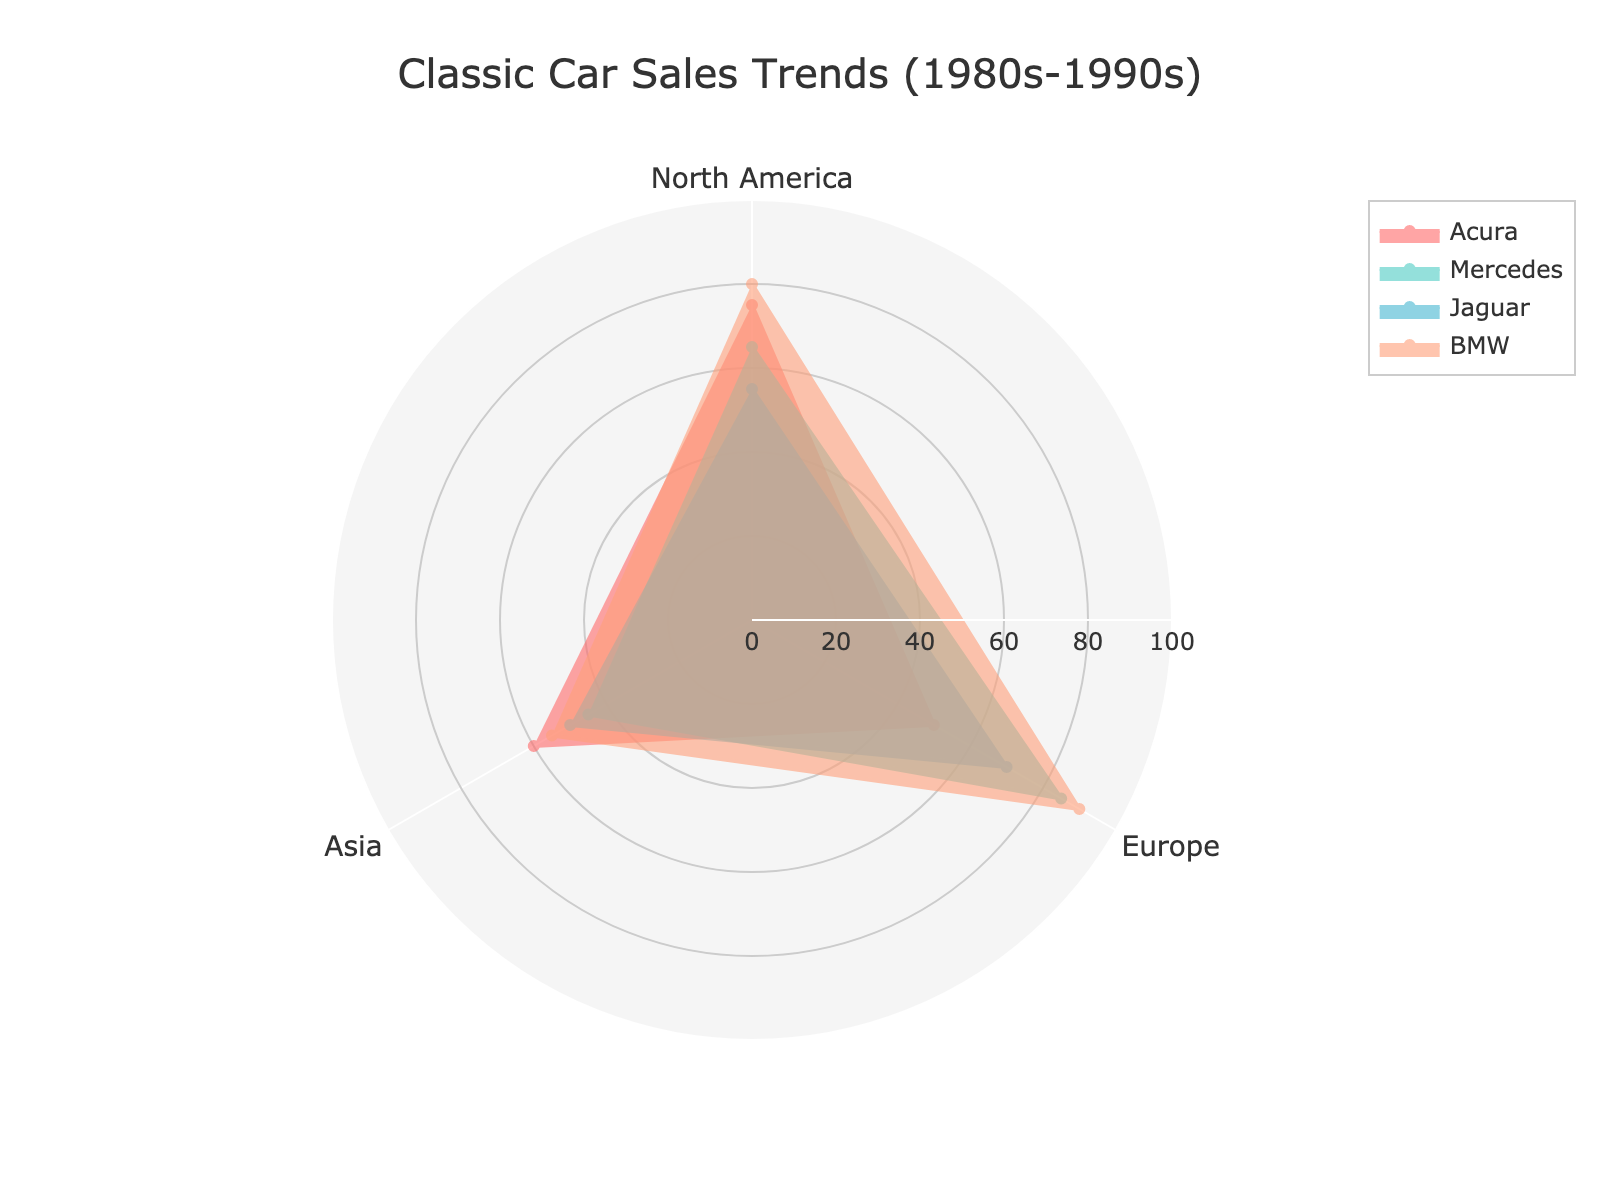How many regions are displayed in the radar chart? The radar chart shows three distinct regions: North America, Europe, and Asia.
Answer: 3 Which car brand has the highest sales in Europe? By looking at the radar chart, the BMW trace reaches the furthest along the European axis, indicating the highest sales.
Answer: BMW What is the average sales value for Acura across all regions? The sales values for Acura in each region are 75 (North America), 50 (Europe), and 60 (Asia). Adding these values and dividing them by 3 gives the average: (75 + 50 + 60) / 3 = 61.7.
Answer: 61.7 Which region shows the lowest sales for Jaguar? The shortest trace for Jaguar can be seen on the Asia axis, indicating the lowest sales.
Answer: Asia How do sales of Mercedes in North America compare to BMW in Asia? The radar chart shows the sales for Mercedes in North America (65) and BMW in Asia (55). Comparing these, Mercedes has higher sales in North America than BMW in Asia.
Answer: Mercedes has higher sales Which brand shows the most consistent sales across all regions? Consistency can be gauged by how similar the values are across the different regions. BMW shows fairly high sales across all regions (80, 90, 55), whereas other brands show more variability.
Answer: BMW If we sum the sales of Mercedes in Europe and Acura in Asia, what is the result? Mercedes in Europe has sales of 85 and Acura in Asia has sales of 60. Summing these values: 85 + 60 = 145.
Answer: 145 Which car brand has the lowest individual sales value, and in which region is it? The lowest individual sales value across all brands is for Jaguar in Asia, with a sales value of 50.
Answer: Jaguar in Asia Compare the sales trend of Acura in North America with the overall trend of Mercedes in Europe and Asia. The sales of Acura in North America (75) are higher than those of Mercedes in both Europe (85) and Asia (45) combined, indicating Acura's higher popularity in North America compared to Mercedes in those two regions.
Answer: Acura higher in North America Which region shows the most significant difference between the highest and lowest sales values among all brands? What is the difference? Europe has the highest sales value for BMW (90) and the lowest for Acura (50), leading to a difference of 90 - 50 = 40.
Answer: Europe, 40 